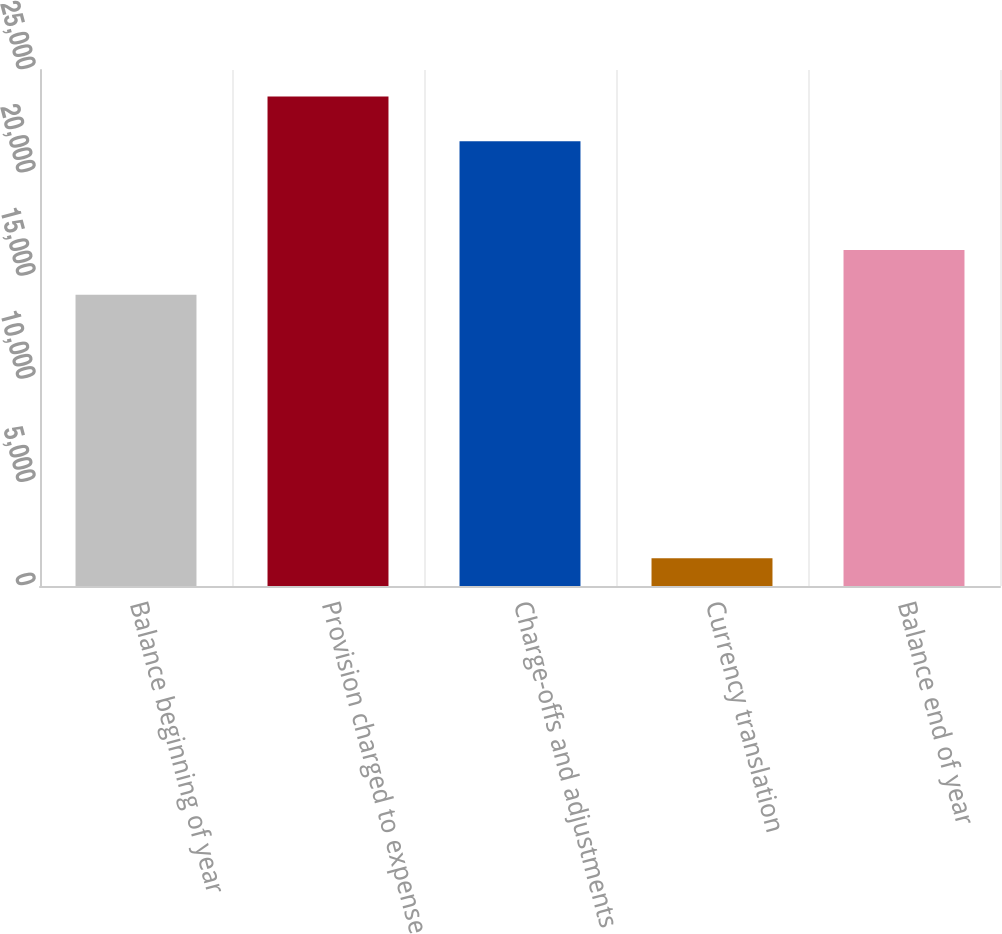Convert chart to OTSL. <chart><loc_0><loc_0><loc_500><loc_500><bar_chart><fcel>Balance beginning of year<fcel>Provision charged to expense<fcel>Charge-offs and adjustments<fcel>Currency translation<fcel>Balance end of year<nl><fcel>14116<fcel>23710.2<fcel>21546<fcel>1348<fcel>16280.2<nl></chart> 